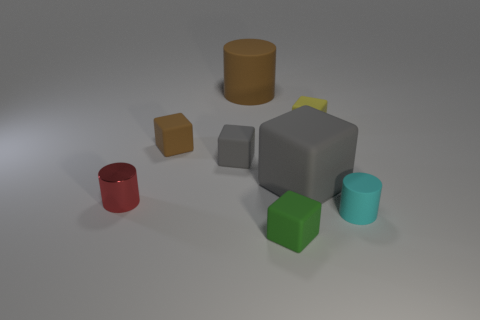There is a brown thing on the right side of the tiny brown cube; is its shape the same as the small shiny thing?
Provide a succinct answer. Yes. Is there anything else that is the same shape as the large gray object?
Make the answer very short. Yes. What number of blocks are either brown rubber objects or big objects?
Give a very brief answer. 2. How many small objects are there?
Provide a succinct answer. 6. There is a brown rubber object that is in front of the big object on the left side of the green thing; what is its size?
Keep it short and to the point. Small. What number of other objects are the same size as the brown matte cylinder?
Keep it short and to the point. 1. What number of metal objects are behind the big block?
Your response must be concise. 0. What is the size of the brown rubber cylinder?
Give a very brief answer. Large. Does the cylinder in front of the red metal thing have the same material as the gray cube left of the big brown rubber object?
Your answer should be very brief. Yes. Are there any matte cubes of the same color as the small matte cylinder?
Offer a terse response. No. 